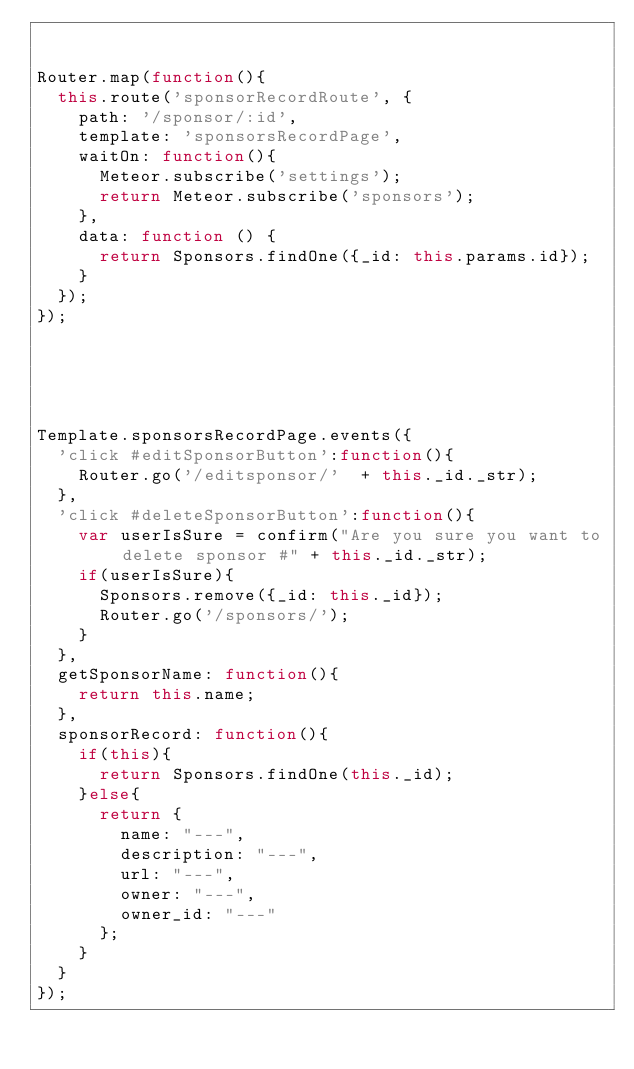<code> <loc_0><loc_0><loc_500><loc_500><_JavaScript_>

Router.map(function(){
  this.route('sponsorRecordRoute', {
    path: '/sponsor/:id',
    template: 'sponsorsRecordPage',
    waitOn: function(){
      Meteor.subscribe('settings');
      return Meteor.subscribe('sponsors');
    },
    data: function () {
      return Sponsors.findOne({_id: this.params.id});
    }
  });
});





Template.sponsorsRecordPage.events({
  'click #editSponsorButton':function(){
    Router.go('/editsponsor/'  + this._id._str);
  },
  'click #deleteSponsorButton':function(){
    var userIsSure = confirm("Are you sure you want to delete sponsor #" + this._id._str);
    if(userIsSure){
      Sponsors.remove({_id: this._id});
      Router.go('/sponsors/');
    }
  },
  getSponsorName: function(){
    return this.name;
  },
  sponsorRecord: function(){
    if(this){
      return Sponsors.findOne(this._id);
    }else{
      return {
        name: "---",
        description: "---",
        url: "---",
        owner: "---",
        owner_id: "---"
      };
    }
  }
});
</code> 